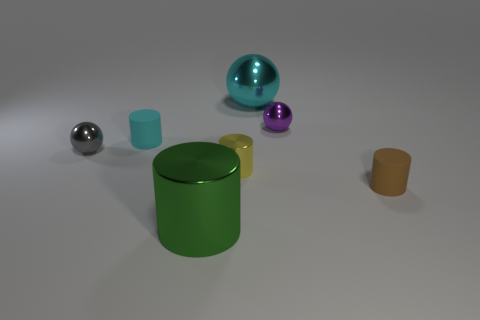Subtract all small balls. How many balls are left? 1 Add 2 metallic cylinders. How many objects exist? 9 Subtract all cyan balls. How many balls are left? 2 Subtract all cylinders. How many objects are left? 3 Subtract all gray cylinders. Subtract all cyan spheres. How many cylinders are left? 4 Subtract 1 yellow cylinders. How many objects are left? 6 Subtract 2 balls. How many balls are left? 1 Subtract all gray cubes. How many cyan cylinders are left? 1 Subtract all tiny purple spheres. Subtract all big green objects. How many objects are left? 5 Add 3 big cyan metallic spheres. How many big cyan metallic spheres are left? 4 